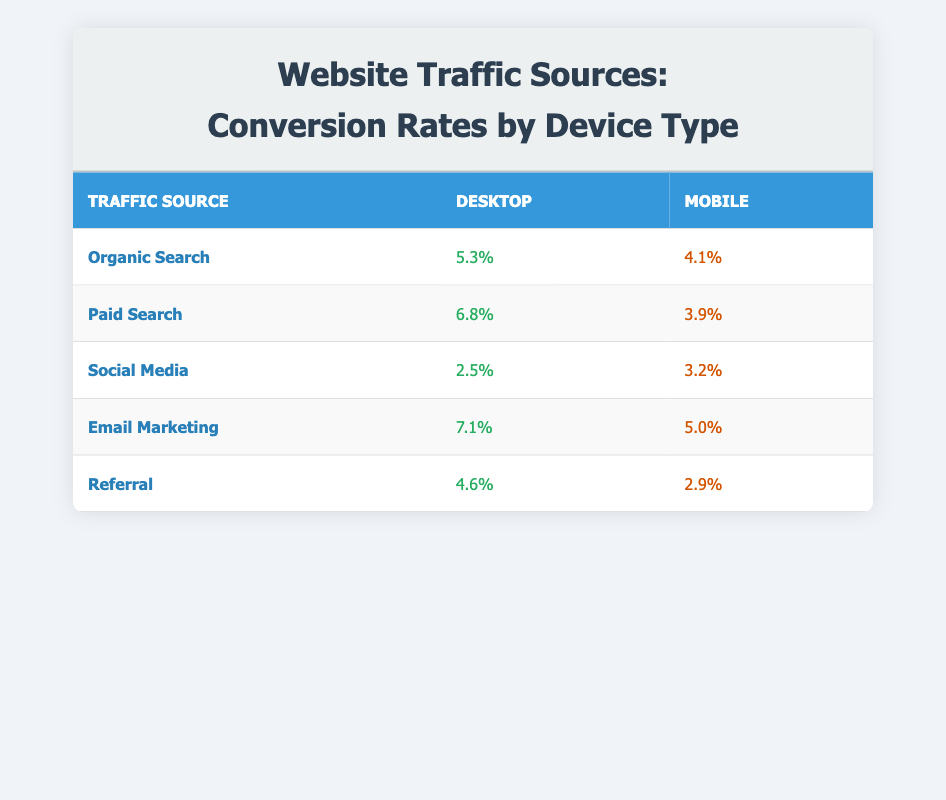What is the conversion rate for Email Marketing on Desktop? According to the table, under the "Email Marketing" row, the conversion rate for the "Desktop" device type is listed as 7.1.
Answer: 7.1 Which traffic source has the highest conversion rate on Mobile? By examining the "Mobile" column for all traffic sources, "Email Marketing" has the highest conversion rate at 5.0, compared to other mobile conversion rates listed.
Answer: Email Marketing Is the conversion rate for Social Media greater on Desktop than on Mobile? Looking at the table, the conversion rate for "Social Media" on Desktop is 2.5, and on Mobile it is 3.2. Since 2.5 is less than 3.2, the statement is false.
Answer: No What is the difference in conversion rates between Paid Search on Desktop and Mobile? For "Paid Search," the Desktop rate is 6.8 and the Mobile rate is 3.9. The difference is calculated as 6.8 - 3.9 = 2.9.
Answer: 2.9 Which traffic sources have a conversion rate lower than 4 on Mobile? Reviewing the "Mobile" column, the sources with conversion rates below 4 are "Paid Search" (3.9), "Social Media" (3.2), and "Referral" (2.9).
Answer: Paid Search, Social Media, Referral What is the average conversion rate for Desktop across all traffic sources? To find the average, add all the Desktop conversion rates: 5.3 + 6.8 + 2.5 + 7.1 + 4.6 = 26.3. Since there are 5 sources, divide by 5 to find the average: 26.3 / 5 = 5.26.
Answer: 5.26 Does Organic Search have a higher conversion rate on Desktop than Referral? For "Organic Search" on Desktop, the rate is 5.3 and for "Referral," it is 4.6. Since 5.3 is greater than 4.6, the answer is yes.
Answer: Yes What is the total conversion rate for Email Marketing across both device types? The conversion rate for Email Marketing on Desktop is 7.1 and on Mobile, it is 5.0. The total is calculated as 7.1 + 5.0 = 12.1.
Answer: 12.1 Which device type has a lower overall average conversion rate across all traffic sources? First, find the average for each device type. For Desktop, the sum is 5.3 + 6.8 + 2.5 + 7.1 + 4.6 = 26.3 and average is 5.26; for Mobile, the sum is 4.1 + 3.9 + 3.2 + 5.0 + 2.9 = 19.1 and average is 3.82. Since 3.82 is less than 5.26, the answer is Mobile.
Answer: Mobile 